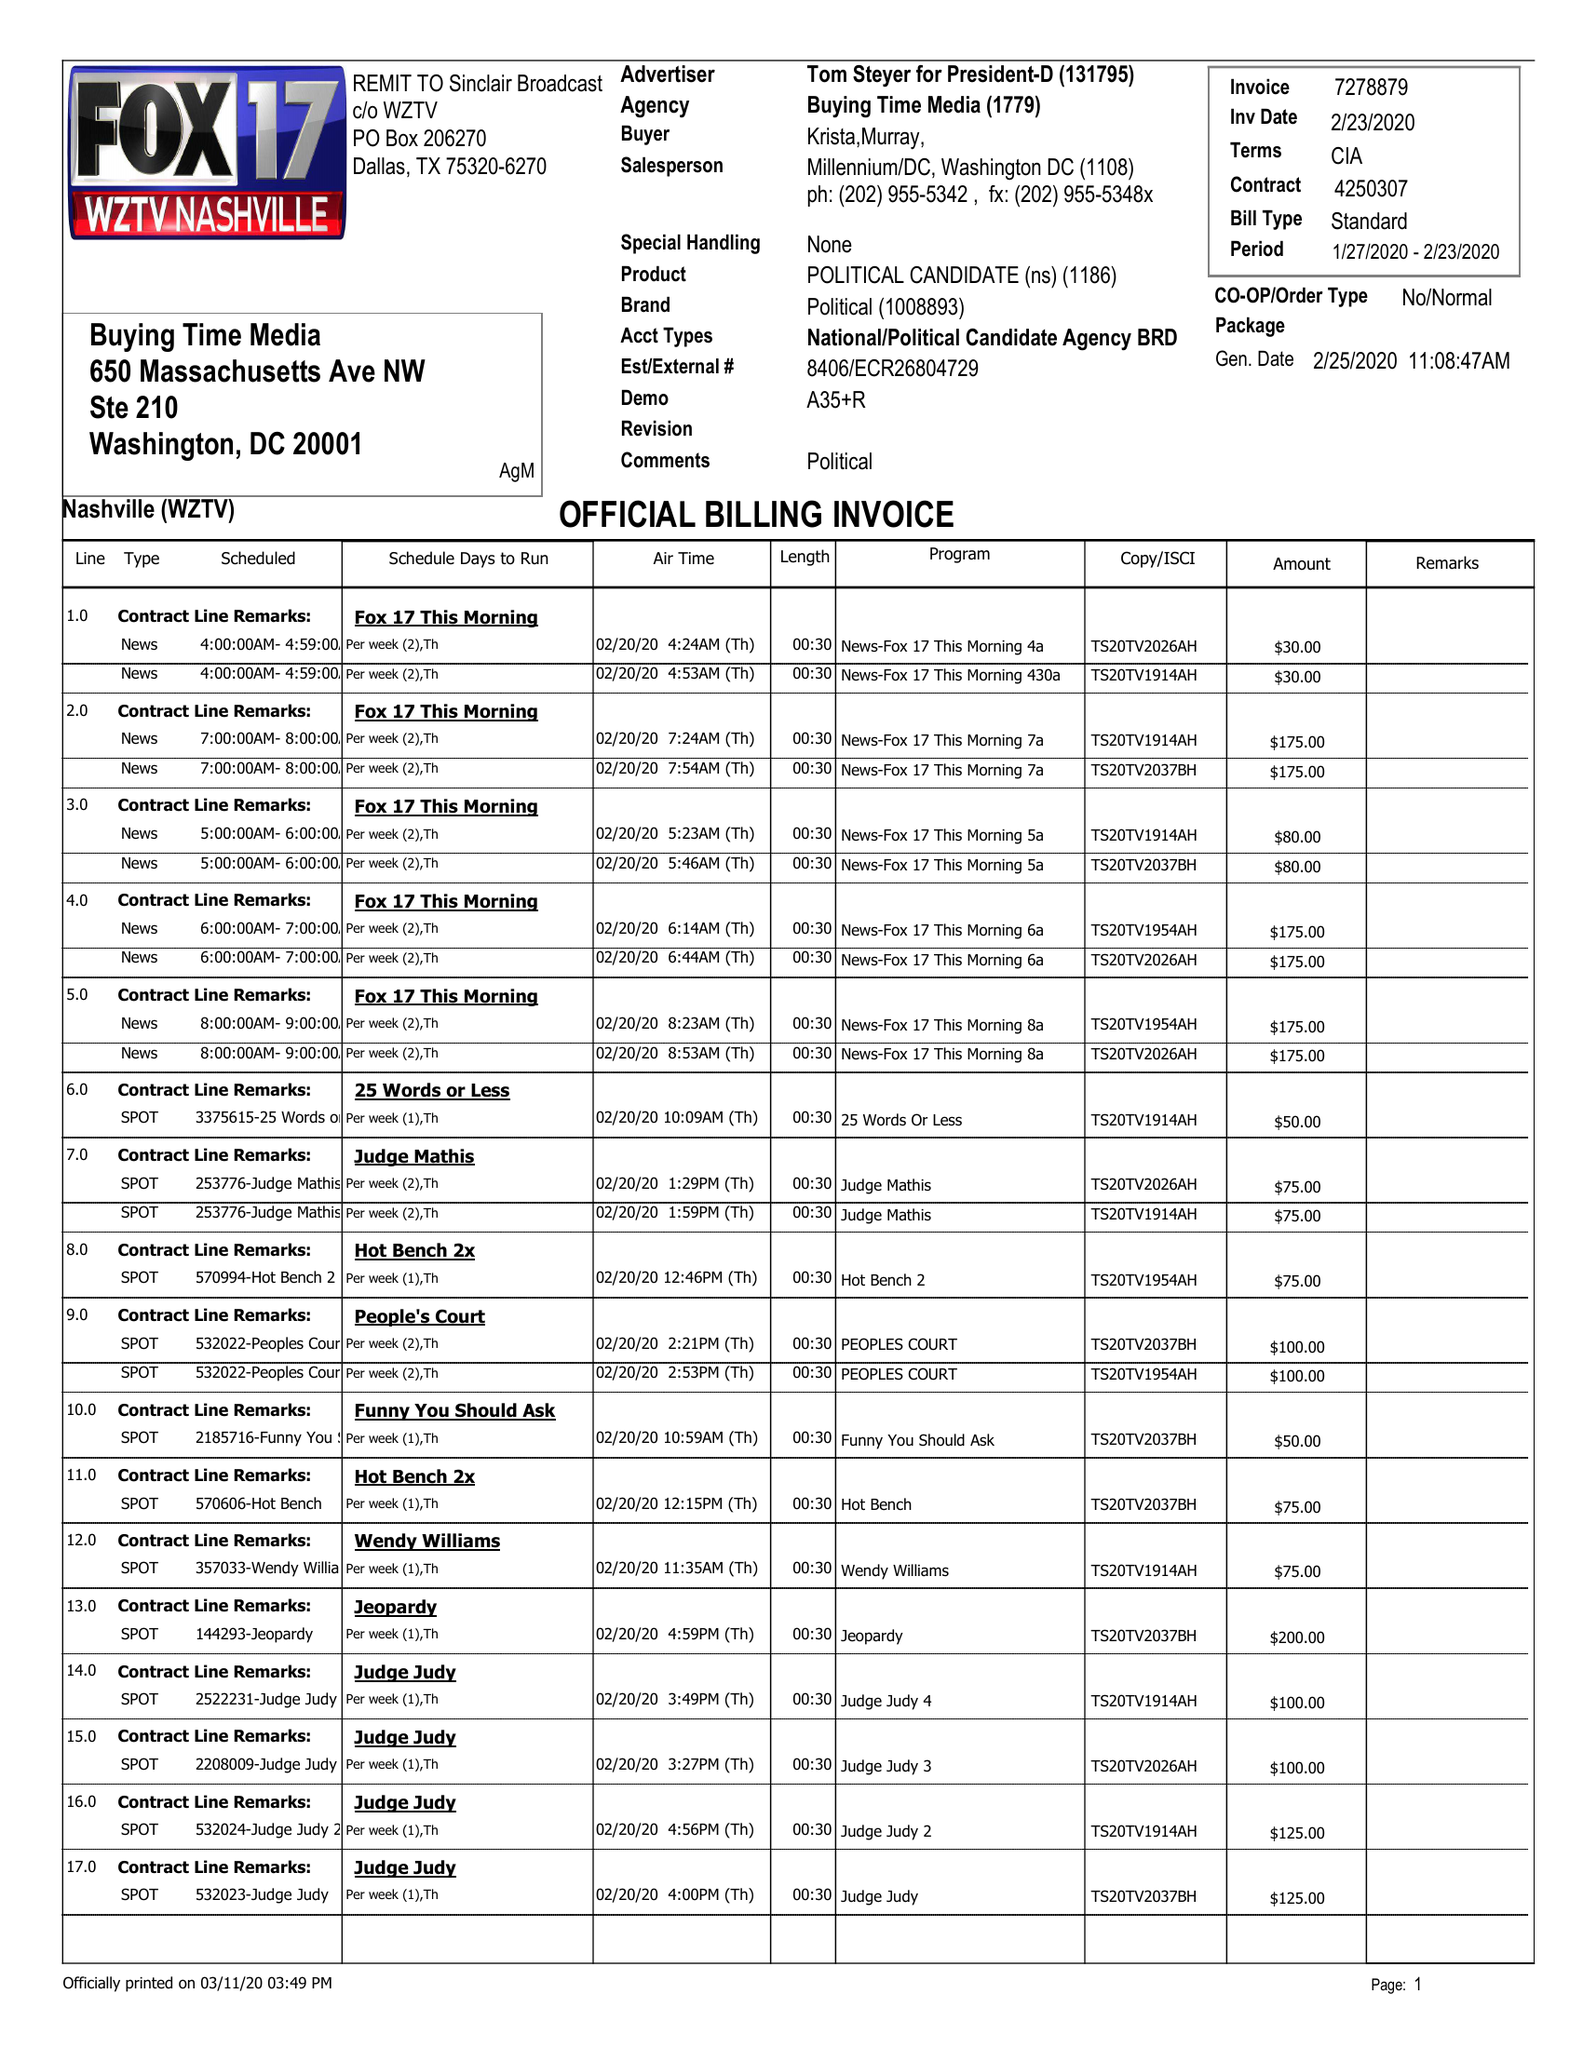What is the value for the contract_num?
Answer the question using a single word or phrase. 4250307 